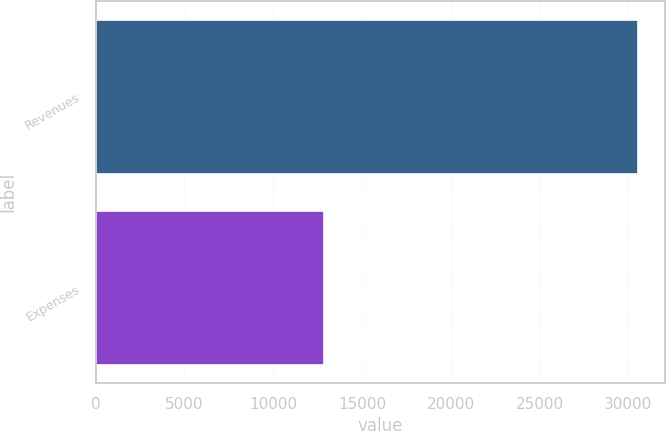<chart> <loc_0><loc_0><loc_500><loc_500><bar_chart><fcel>Revenues<fcel>Expenses<nl><fcel>30517<fcel>12795<nl></chart> 